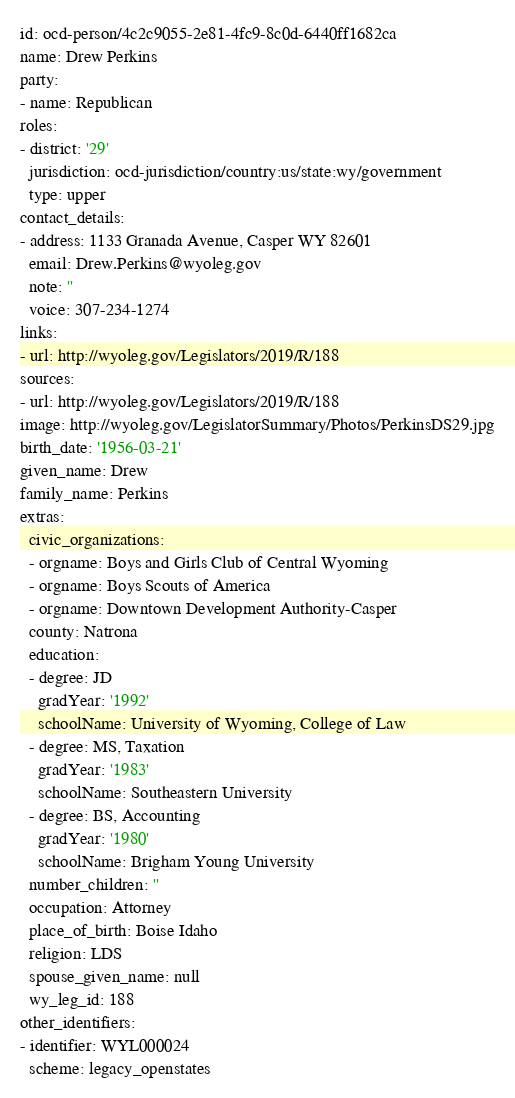<code> <loc_0><loc_0><loc_500><loc_500><_YAML_>id: ocd-person/4c2c9055-2e81-4fc9-8c0d-6440ff1682ca
name: Drew Perkins
party:
- name: Republican
roles:
- district: '29'
  jurisdiction: ocd-jurisdiction/country:us/state:wy/government
  type: upper
contact_details:
- address: 1133 Granada Avenue, Casper WY 82601
  email: Drew.Perkins@wyoleg.gov
  note: ''
  voice: 307-234-1274
links:
- url: http://wyoleg.gov/Legislators/2019/R/188
sources:
- url: http://wyoleg.gov/Legislators/2019/R/188
image: http://wyoleg.gov/LegislatorSummary/Photos/PerkinsDS29.jpg
birth_date: '1956-03-21'
given_name: Drew
family_name: Perkins
extras:
  civic_organizations:
  - orgname: Boys and Girls Club of Central Wyoming
  - orgname: Boys Scouts of America
  - orgname: Downtown Development Authority-Casper
  county: Natrona
  education:
  - degree: JD
    gradYear: '1992'
    schoolName: University of Wyoming, College of Law
  - degree: MS, Taxation
    gradYear: '1983'
    schoolName: Southeastern University
  - degree: BS, Accounting
    gradYear: '1980'
    schoolName: Brigham Young University
  number_children: ''
  occupation: Attorney
  place_of_birth: Boise Idaho
  religion: LDS
  spouse_given_name: null
  wy_leg_id: 188
other_identifiers:
- identifier: WYL000024
  scheme: legacy_openstates
</code> 